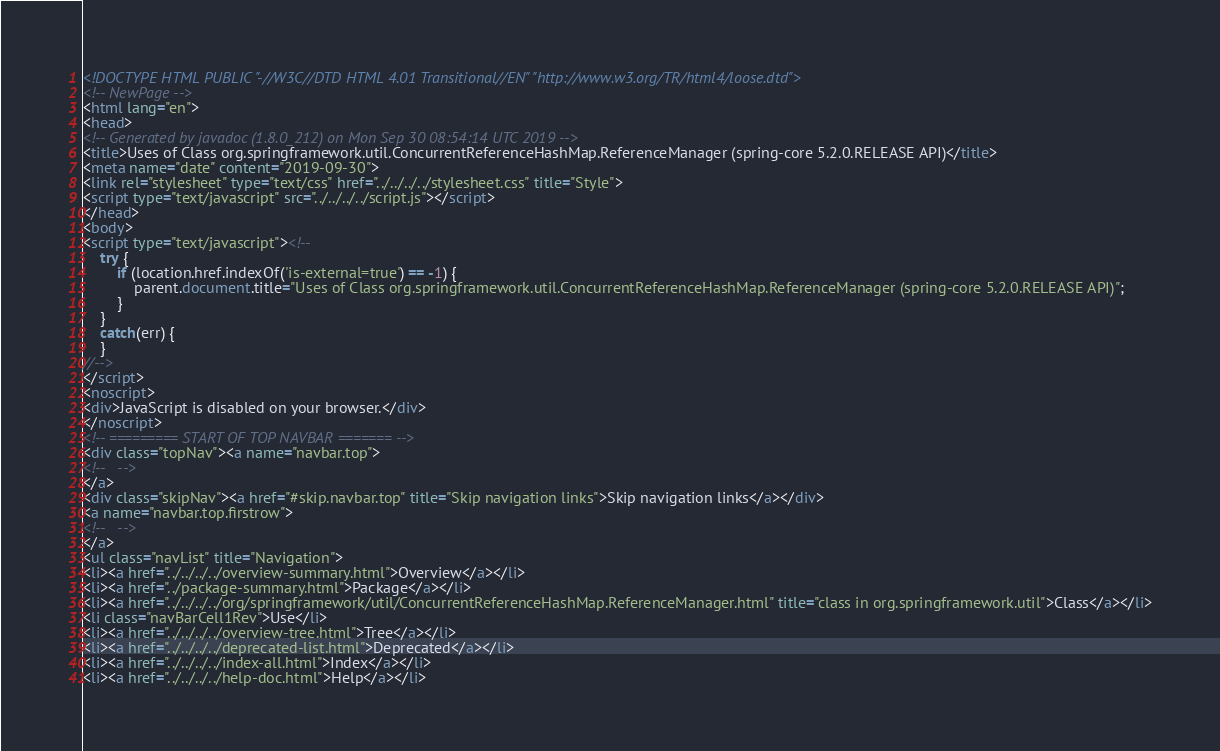Convert code to text. <code><loc_0><loc_0><loc_500><loc_500><_HTML_><!DOCTYPE HTML PUBLIC "-//W3C//DTD HTML 4.01 Transitional//EN" "http://www.w3.org/TR/html4/loose.dtd">
<!-- NewPage -->
<html lang="en">
<head>
<!-- Generated by javadoc (1.8.0_212) on Mon Sep 30 08:54:14 UTC 2019 -->
<title>Uses of Class org.springframework.util.ConcurrentReferenceHashMap.ReferenceManager (spring-core 5.2.0.RELEASE API)</title>
<meta name="date" content="2019-09-30">
<link rel="stylesheet" type="text/css" href="../../../../stylesheet.css" title="Style">
<script type="text/javascript" src="../../../../script.js"></script>
</head>
<body>
<script type="text/javascript"><!--
    try {
        if (location.href.indexOf('is-external=true') == -1) {
            parent.document.title="Uses of Class org.springframework.util.ConcurrentReferenceHashMap.ReferenceManager (spring-core 5.2.0.RELEASE API)";
        }
    }
    catch(err) {
    }
//-->
</script>
<noscript>
<div>JavaScript is disabled on your browser.</div>
</noscript>
<!-- ========= START OF TOP NAVBAR ======= -->
<div class="topNav"><a name="navbar.top">
<!--   -->
</a>
<div class="skipNav"><a href="#skip.navbar.top" title="Skip navigation links">Skip navigation links</a></div>
<a name="navbar.top.firstrow">
<!--   -->
</a>
<ul class="navList" title="Navigation">
<li><a href="../../../../overview-summary.html">Overview</a></li>
<li><a href="../package-summary.html">Package</a></li>
<li><a href="../../../../org/springframework/util/ConcurrentReferenceHashMap.ReferenceManager.html" title="class in org.springframework.util">Class</a></li>
<li class="navBarCell1Rev">Use</li>
<li><a href="../../../../overview-tree.html">Tree</a></li>
<li><a href="../../../../deprecated-list.html">Deprecated</a></li>
<li><a href="../../../../index-all.html">Index</a></li>
<li><a href="../../../../help-doc.html">Help</a></li></code> 